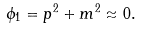Convert formula to latex. <formula><loc_0><loc_0><loc_500><loc_500>\phi _ { 1 } = p ^ { 2 } + m ^ { 2 } \approx 0 .</formula> 